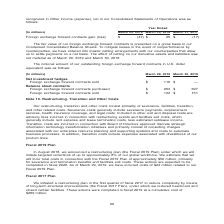According to Nortonlifelock's financial document, What does the table show? notional amount of our outstanding foreign exchange forward contracts in U.S. dollar equivalent was as follows. The document states: "The notional amount of our outstanding foreign exchange forward contracts in U.S. dollar equivalent was as follows:..." Also, How is the fair value of foreign exchange forward contracts presented? on a gross basis in our Condensed Consolidated Balance Sheets. The document states: "r foreign exchange forward contracts is presented on a gross basis in our Condensed Consolidated Balance Sheets. To mitigate losses in the event of no..." Also, What is the Foreign exchange forward contracts sold as of March 29, 2019? According to the financial document, $116 (in millions). The relevant text states: "hedges Foreign exchange forward contracts sold $ 116 $ — Balance sheet contracts Foreign exchange forward contracts purchased $ 963 $ 697 Foreign exchan..." Also, can you calculate: What is the total Foreign exchange forward contracts purchased for March 29, 2019 and March 30, 2018? Based on the calculation: 963+697, the result is 1660 (in millions). This is based on the information: "ts Foreign exchange forward contracts purchased $ 963 $ 697 Foreign exchange forward contracts sold $ 122 $ 151 eign exchange forward contracts purchased $ 963 $ 697 Foreign exchange forward contracts..." The key data points involved are: 697, 963. Also, can you calculate: What is the total Foreign exchange forward contracts sold for March 29, 2019 and March 30, 2018? Based on the calculation: 122+151, the result is 273 (in millions). This is based on the information: "3 $ 697 Foreign exchange forward contracts sold $ 122 $ 151 7 Foreign exchange forward contracts sold $ 122 $ 151..." The key data points involved are: 122, 151. Also, can you calculate: What is the change between Foreign exchange forward contracts purchased for March 29, 2019 and March 30, 2018? Based on the calculation: 963-697, the result is 266 (in millions). This is based on the information: "ts Foreign exchange forward contracts purchased $ 963 $ 697 Foreign exchange forward contracts sold $ 122 $ 151 eign exchange forward contracts purchased $ 963 $ 697 Foreign exchange forward contracts..." The key data points involved are: 697, 963. 